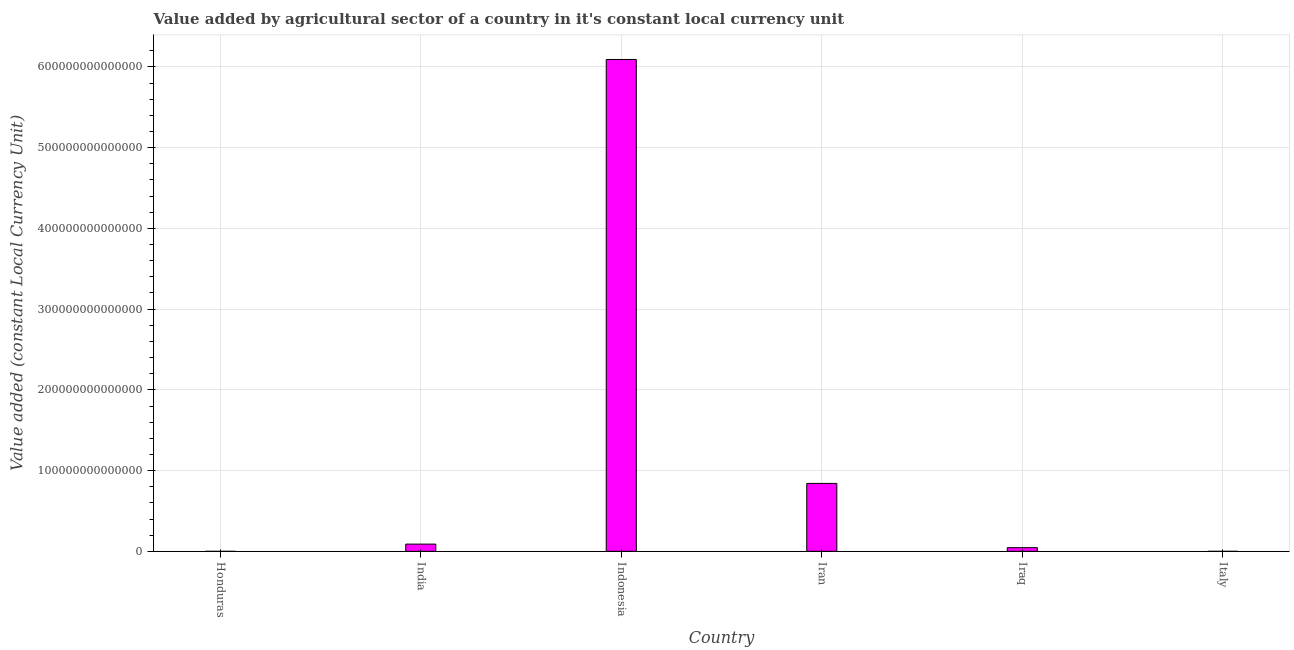Does the graph contain any zero values?
Provide a short and direct response. No. Does the graph contain grids?
Make the answer very short. Yes. What is the title of the graph?
Your response must be concise. Value added by agricultural sector of a country in it's constant local currency unit. What is the label or title of the Y-axis?
Your response must be concise. Value added (constant Local Currency Unit). What is the value added by agriculture sector in Honduras?
Your answer should be compact. 1.32e+1. Across all countries, what is the maximum value added by agriculture sector?
Your response must be concise. 6.09e+14. Across all countries, what is the minimum value added by agriculture sector?
Keep it short and to the point. 1.32e+1. In which country was the value added by agriculture sector maximum?
Give a very brief answer. Indonesia. In which country was the value added by agriculture sector minimum?
Ensure brevity in your answer.  Honduras. What is the sum of the value added by agriculture sector?
Offer a very short reply. 7.07e+14. What is the difference between the value added by agriculture sector in India and Italy?
Ensure brevity in your answer.  8.97e+12. What is the average value added by agriculture sector per country?
Keep it short and to the point. 1.18e+14. What is the median value added by agriculture sector?
Your answer should be very brief. 6.79e+12. What is the ratio of the value added by agriculture sector in Honduras to that in Iran?
Make the answer very short. 0. Is the value added by agriculture sector in Iraq less than that in Italy?
Make the answer very short. No. Is the difference between the value added by agriculture sector in Honduras and India greater than the difference between any two countries?
Your response must be concise. No. What is the difference between the highest and the second highest value added by agriculture sector?
Your answer should be compact. 5.25e+14. What is the difference between the highest and the lowest value added by agriculture sector?
Offer a very short reply. 6.09e+14. What is the difference between two consecutive major ticks on the Y-axis?
Offer a very short reply. 1.00e+14. Are the values on the major ticks of Y-axis written in scientific E-notation?
Your answer should be compact. No. What is the Value added (constant Local Currency Unit) of Honduras?
Your answer should be compact. 1.32e+1. What is the Value added (constant Local Currency Unit) of India?
Ensure brevity in your answer.  8.99e+12. What is the Value added (constant Local Currency Unit) in Indonesia?
Your answer should be compact. 6.09e+14. What is the Value added (constant Local Currency Unit) in Iran?
Your answer should be compact. 8.41e+13. What is the Value added (constant Local Currency Unit) of Iraq?
Keep it short and to the point. 4.59e+12. What is the Value added (constant Local Currency Unit) in Italy?
Offer a very short reply. 2.67e+1. What is the difference between the Value added (constant Local Currency Unit) in Honduras and India?
Offer a terse response. -8.98e+12. What is the difference between the Value added (constant Local Currency Unit) in Honduras and Indonesia?
Provide a short and direct response. -6.09e+14. What is the difference between the Value added (constant Local Currency Unit) in Honduras and Iran?
Provide a succinct answer. -8.41e+13. What is the difference between the Value added (constant Local Currency Unit) in Honduras and Iraq?
Give a very brief answer. -4.58e+12. What is the difference between the Value added (constant Local Currency Unit) in Honduras and Italy?
Provide a short and direct response. -1.35e+1. What is the difference between the Value added (constant Local Currency Unit) in India and Indonesia?
Your answer should be compact. -6.00e+14. What is the difference between the Value added (constant Local Currency Unit) in India and Iran?
Provide a succinct answer. -7.52e+13. What is the difference between the Value added (constant Local Currency Unit) in India and Iraq?
Provide a succinct answer. 4.40e+12. What is the difference between the Value added (constant Local Currency Unit) in India and Italy?
Make the answer very short. 8.97e+12. What is the difference between the Value added (constant Local Currency Unit) in Indonesia and Iran?
Give a very brief answer. 5.25e+14. What is the difference between the Value added (constant Local Currency Unit) in Indonesia and Iraq?
Offer a very short reply. 6.05e+14. What is the difference between the Value added (constant Local Currency Unit) in Indonesia and Italy?
Offer a terse response. 6.09e+14. What is the difference between the Value added (constant Local Currency Unit) in Iran and Iraq?
Your answer should be compact. 7.96e+13. What is the difference between the Value added (constant Local Currency Unit) in Iran and Italy?
Make the answer very short. 8.41e+13. What is the difference between the Value added (constant Local Currency Unit) in Iraq and Italy?
Provide a succinct answer. 4.56e+12. What is the ratio of the Value added (constant Local Currency Unit) in Honduras to that in Iran?
Ensure brevity in your answer.  0. What is the ratio of the Value added (constant Local Currency Unit) in Honduras to that in Iraq?
Make the answer very short. 0. What is the ratio of the Value added (constant Local Currency Unit) in Honduras to that in Italy?
Ensure brevity in your answer.  0.49. What is the ratio of the Value added (constant Local Currency Unit) in India to that in Indonesia?
Make the answer very short. 0.01. What is the ratio of the Value added (constant Local Currency Unit) in India to that in Iran?
Keep it short and to the point. 0.11. What is the ratio of the Value added (constant Local Currency Unit) in India to that in Iraq?
Ensure brevity in your answer.  1.96. What is the ratio of the Value added (constant Local Currency Unit) in India to that in Italy?
Your answer should be very brief. 337.28. What is the ratio of the Value added (constant Local Currency Unit) in Indonesia to that in Iran?
Provide a succinct answer. 7.24. What is the ratio of the Value added (constant Local Currency Unit) in Indonesia to that in Iraq?
Your answer should be very brief. 132.76. What is the ratio of the Value added (constant Local Currency Unit) in Indonesia to that in Italy?
Your answer should be compact. 2.28e+04. What is the ratio of the Value added (constant Local Currency Unit) in Iran to that in Iraq?
Keep it short and to the point. 18.34. What is the ratio of the Value added (constant Local Currency Unit) in Iran to that in Italy?
Provide a short and direct response. 3156.1. What is the ratio of the Value added (constant Local Currency Unit) in Iraq to that in Italy?
Your answer should be very brief. 172.09. 